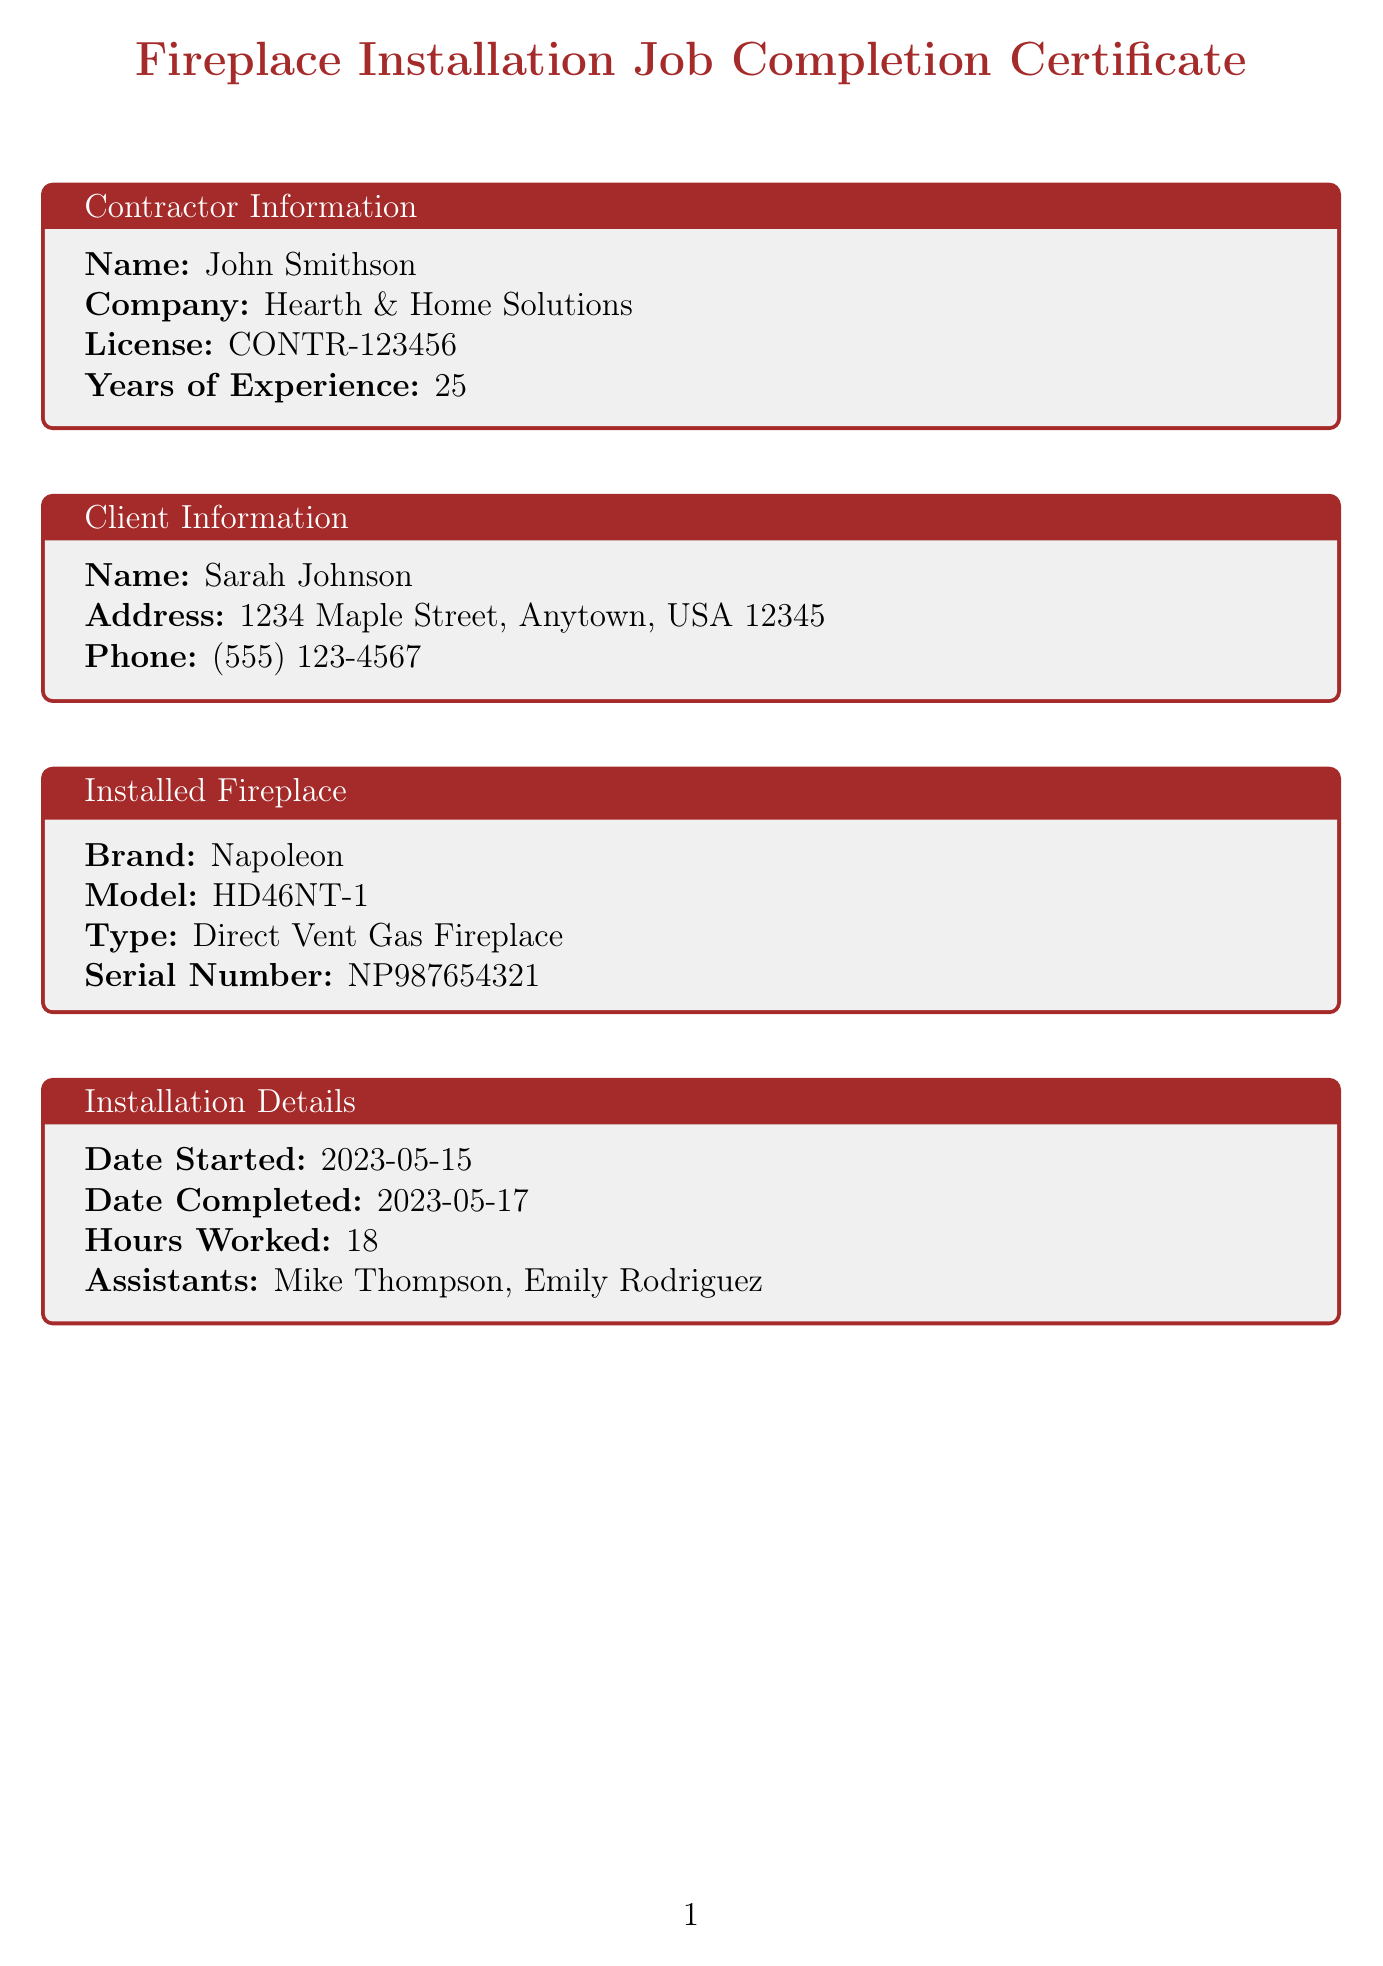What is the contractor's name? The contractor's name is detailed under the contractor information section of the document.
Answer: John Smithson What is the model of the installed fireplace? The model is listed in the installed fireplace section.
Answer: HD46NT-1 What date was the installation started? The date the installation started is mentioned in the installation details section.
Answer: 2023-05-15 Who conducted the final inspection? The inspector's name is found in the final inspection results section.
Answer: Robert Chen What was the venting efficiency reported? The venting efficiency is specified in the final inspection results.
Answer: 98% How many hours were worked on the installation? The total hours worked is provided in the installation details section.
Answer: 18 What are the safety features listed? The safety features are enumerated under the safety features section; it's a list.
Answer: Carbon monoxide detector installed, automatic shut-off valve, child-safety screen What warranty duration is provided for the installation workmanship? The warranty duration for workmanship is listed in the warranties section of the document.
Answer: 5 years What was the outcome of the operation test? The outcome of the operation test is included in the final inspection results.
Answer: Successful 